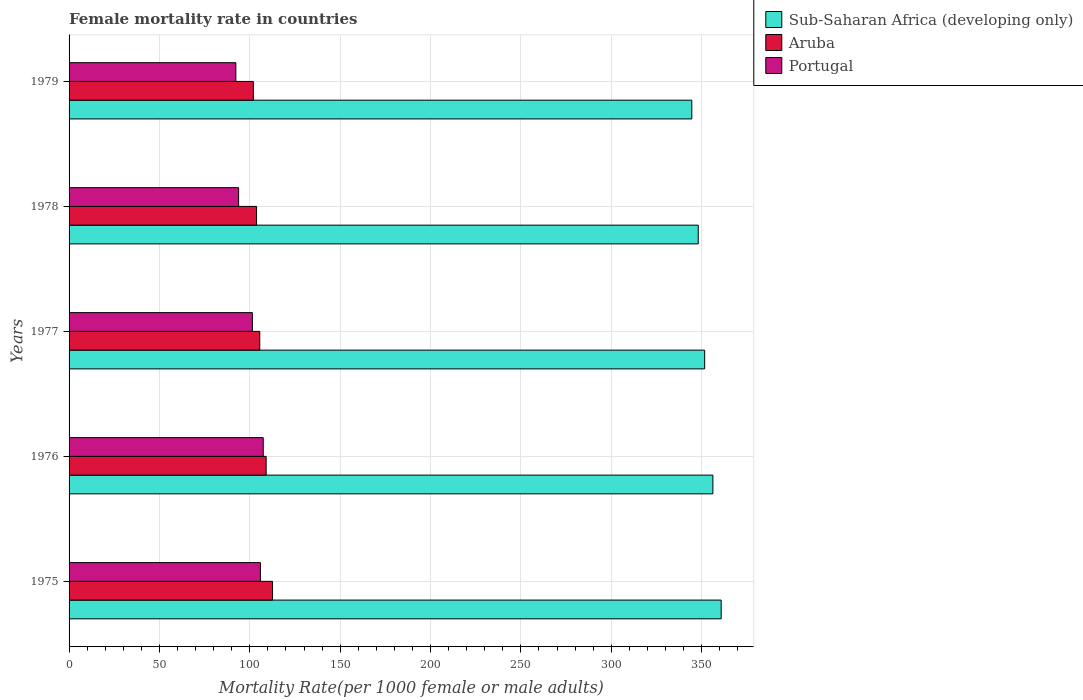How many groups of bars are there?
Your answer should be compact. 5. Are the number of bars per tick equal to the number of legend labels?
Keep it short and to the point. Yes. How many bars are there on the 1st tick from the top?
Give a very brief answer. 3. In how many cases, is the number of bars for a given year not equal to the number of legend labels?
Offer a very short reply. 0. What is the female mortality rate in Aruba in 1978?
Give a very brief answer. 103.74. Across all years, what is the maximum female mortality rate in Portugal?
Make the answer very short. 107.44. Across all years, what is the minimum female mortality rate in Portugal?
Ensure brevity in your answer.  92.29. In which year was the female mortality rate in Portugal maximum?
Make the answer very short. 1976. In which year was the female mortality rate in Portugal minimum?
Offer a very short reply. 1979. What is the total female mortality rate in Sub-Saharan Africa (developing only) in the graph?
Keep it short and to the point. 1761.43. What is the difference between the female mortality rate in Sub-Saharan Africa (developing only) in 1975 and that in 1976?
Your answer should be compact. 4.58. What is the difference between the female mortality rate in Portugal in 1977 and the female mortality rate in Sub-Saharan Africa (developing only) in 1976?
Offer a terse response. -254.81. What is the average female mortality rate in Sub-Saharan Africa (developing only) per year?
Your answer should be compact. 352.29. In the year 1979, what is the difference between the female mortality rate in Sub-Saharan Africa (developing only) and female mortality rate in Portugal?
Offer a terse response. 252.28. What is the ratio of the female mortality rate in Sub-Saharan Africa (developing only) in 1975 to that in 1979?
Your answer should be very brief. 1.05. Is the female mortality rate in Portugal in 1975 less than that in 1976?
Your answer should be compact. Yes. Is the difference between the female mortality rate in Sub-Saharan Africa (developing only) in 1978 and 1979 greater than the difference between the female mortality rate in Portugal in 1978 and 1979?
Ensure brevity in your answer.  Yes. What is the difference between the highest and the second highest female mortality rate in Portugal?
Keep it short and to the point. 1.57. What is the difference between the highest and the lowest female mortality rate in Portugal?
Make the answer very short. 15.15. In how many years, is the female mortality rate in Portugal greater than the average female mortality rate in Portugal taken over all years?
Offer a terse response. 3. What does the 3rd bar from the top in 1979 represents?
Your answer should be very brief. Sub-Saharan Africa (developing only). What does the 1st bar from the bottom in 1978 represents?
Give a very brief answer. Sub-Saharan Africa (developing only). How many bars are there?
Make the answer very short. 15. What is the title of the graph?
Provide a short and direct response. Female mortality rate in countries. Does "Sweden" appear as one of the legend labels in the graph?
Your response must be concise. No. What is the label or title of the X-axis?
Provide a short and direct response. Mortality Rate(per 1000 female or male adults). What is the Mortality Rate(per 1000 female or male adults) in Sub-Saharan Africa (developing only) in 1975?
Offer a very short reply. 360.82. What is the Mortality Rate(per 1000 female or male adults) of Aruba in 1975?
Give a very brief answer. 112.58. What is the Mortality Rate(per 1000 female or male adults) in Portugal in 1975?
Your answer should be compact. 105.87. What is the Mortality Rate(per 1000 female or male adults) in Sub-Saharan Africa (developing only) in 1976?
Offer a very short reply. 356.24. What is the Mortality Rate(per 1000 female or male adults) in Aruba in 1976?
Offer a very short reply. 109.05. What is the Mortality Rate(per 1000 female or male adults) in Portugal in 1976?
Your answer should be compact. 107.44. What is the Mortality Rate(per 1000 female or male adults) in Sub-Saharan Africa (developing only) in 1977?
Your answer should be compact. 351.68. What is the Mortality Rate(per 1000 female or male adults) of Aruba in 1977?
Your response must be concise. 105.51. What is the Mortality Rate(per 1000 female or male adults) in Portugal in 1977?
Your answer should be compact. 101.43. What is the Mortality Rate(per 1000 female or male adults) in Sub-Saharan Africa (developing only) in 1978?
Make the answer very short. 348.13. What is the Mortality Rate(per 1000 female or male adults) of Aruba in 1978?
Give a very brief answer. 103.74. What is the Mortality Rate(per 1000 female or male adults) of Portugal in 1978?
Offer a very short reply. 93.82. What is the Mortality Rate(per 1000 female or male adults) of Sub-Saharan Africa (developing only) in 1979?
Provide a succinct answer. 344.57. What is the Mortality Rate(per 1000 female or male adults) in Aruba in 1979?
Provide a succinct answer. 101.97. What is the Mortality Rate(per 1000 female or male adults) of Portugal in 1979?
Give a very brief answer. 92.29. Across all years, what is the maximum Mortality Rate(per 1000 female or male adults) in Sub-Saharan Africa (developing only)?
Your answer should be very brief. 360.82. Across all years, what is the maximum Mortality Rate(per 1000 female or male adults) of Aruba?
Give a very brief answer. 112.58. Across all years, what is the maximum Mortality Rate(per 1000 female or male adults) in Portugal?
Provide a succinct answer. 107.44. Across all years, what is the minimum Mortality Rate(per 1000 female or male adults) of Sub-Saharan Africa (developing only)?
Offer a very short reply. 344.57. Across all years, what is the minimum Mortality Rate(per 1000 female or male adults) in Aruba?
Give a very brief answer. 101.97. Across all years, what is the minimum Mortality Rate(per 1000 female or male adults) of Portugal?
Offer a terse response. 92.29. What is the total Mortality Rate(per 1000 female or male adults) of Sub-Saharan Africa (developing only) in the graph?
Provide a short and direct response. 1761.43. What is the total Mortality Rate(per 1000 female or male adults) in Aruba in the graph?
Offer a very short reply. 532.85. What is the total Mortality Rate(per 1000 female or male adults) in Portugal in the graph?
Your response must be concise. 500.85. What is the difference between the Mortality Rate(per 1000 female or male adults) in Sub-Saharan Africa (developing only) in 1975 and that in 1976?
Provide a succinct answer. 4.58. What is the difference between the Mortality Rate(per 1000 female or male adults) in Aruba in 1975 and that in 1976?
Make the answer very short. 3.54. What is the difference between the Mortality Rate(per 1000 female or male adults) of Portugal in 1975 and that in 1976?
Ensure brevity in your answer.  -1.57. What is the difference between the Mortality Rate(per 1000 female or male adults) in Sub-Saharan Africa (developing only) in 1975 and that in 1977?
Provide a succinct answer. 9.14. What is the difference between the Mortality Rate(per 1000 female or male adults) of Aruba in 1975 and that in 1977?
Offer a very short reply. 7.07. What is the difference between the Mortality Rate(per 1000 female or male adults) of Portugal in 1975 and that in 1977?
Ensure brevity in your answer.  4.44. What is the difference between the Mortality Rate(per 1000 female or male adults) of Sub-Saharan Africa (developing only) in 1975 and that in 1978?
Make the answer very short. 12.69. What is the difference between the Mortality Rate(per 1000 female or male adults) of Aruba in 1975 and that in 1978?
Offer a very short reply. 8.84. What is the difference between the Mortality Rate(per 1000 female or male adults) of Portugal in 1975 and that in 1978?
Keep it short and to the point. 12.05. What is the difference between the Mortality Rate(per 1000 female or male adults) in Sub-Saharan Africa (developing only) in 1975 and that in 1979?
Your answer should be very brief. 16.25. What is the difference between the Mortality Rate(per 1000 female or male adults) in Aruba in 1975 and that in 1979?
Offer a very short reply. 10.62. What is the difference between the Mortality Rate(per 1000 female or male adults) of Portugal in 1975 and that in 1979?
Keep it short and to the point. 13.58. What is the difference between the Mortality Rate(per 1000 female or male adults) of Sub-Saharan Africa (developing only) in 1976 and that in 1977?
Give a very brief answer. 4.56. What is the difference between the Mortality Rate(per 1000 female or male adults) in Aruba in 1976 and that in 1977?
Your response must be concise. 3.54. What is the difference between the Mortality Rate(per 1000 female or male adults) in Portugal in 1976 and that in 1977?
Offer a terse response. 6.01. What is the difference between the Mortality Rate(per 1000 female or male adults) in Sub-Saharan Africa (developing only) in 1976 and that in 1978?
Give a very brief answer. 8.11. What is the difference between the Mortality Rate(per 1000 female or male adults) of Aruba in 1976 and that in 1978?
Your answer should be compact. 5.31. What is the difference between the Mortality Rate(per 1000 female or male adults) in Portugal in 1976 and that in 1978?
Provide a succinct answer. 13.62. What is the difference between the Mortality Rate(per 1000 female or male adults) in Sub-Saharan Africa (developing only) in 1976 and that in 1979?
Offer a terse response. 11.67. What is the difference between the Mortality Rate(per 1000 female or male adults) in Aruba in 1976 and that in 1979?
Offer a very short reply. 7.08. What is the difference between the Mortality Rate(per 1000 female or male adults) of Portugal in 1976 and that in 1979?
Ensure brevity in your answer.  15.15. What is the difference between the Mortality Rate(per 1000 female or male adults) in Sub-Saharan Africa (developing only) in 1977 and that in 1978?
Your response must be concise. 3.55. What is the difference between the Mortality Rate(per 1000 female or male adults) of Aruba in 1977 and that in 1978?
Keep it short and to the point. 1.77. What is the difference between the Mortality Rate(per 1000 female or male adults) in Portugal in 1977 and that in 1978?
Provide a short and direct response. 7.61. What is the difference between the Mortality Rate(per 1000 female or male adults) in Sub-Saharan Africa (developing only) in 1977 and that in 1979?
Your answer should be compact. 7.11. What is the difference between the Mortality Rate(per 1000 female or male adults) in Aruba in 1977 and that in 1979?
Keep it short and to the point. 3.54. What is the difference between the Mortality Rate(per 1000 female or male adults) of Portugal in 1977 and that in 1979?
Your answer should be compact. 9.14. What is the difference between the Mortality Rate(per 1000 female or male adults) of Sub-Saharan Africa (developing only) in 1978 and that in 1979?
Give a very brief answer. 3.56. What is the difference between the Mortality Rate(per 1000 female or male adults) in Aruba in 1978 and that in 1979?
Your answer should be compact. 1.77. What is the difference between the Mortality Rate(per 1000 female or male adults) of Portugal in 1978 and that in 1979?
Your answer should be very brief. 1.53. What is the difference between the Mortality Rate(per 1000 female or male adults) of Sub-Saharan Africa (developing only) in 1975 and the Mortality Rate(per 1000 female or male adults) of Aruba in 1976?
Your answer should be compact. 251.77. What is the difference between the Mortality Rate(per 1000 female or male adults) of Sub-Saharan Africa (developing only) in 1975 and the Mortality Rate(per 1000 female or male adults) of Portugal in 1976?
Your answer should be very brief. 253.38. What is the difference between the Mortality Rate(per 1000 female or male adults) in Aruba in 1975 and the Mortality Rate(per 1000 female or male adults) in Portugal in 1976?
Provide a short and direct response. 5.15. What is the difference between the Mortality Rate(per 1000 female or male adults) of Sub-Saharan Africa (developing only) in 1975 and the Mortality Rate(per 1000 female or male adults) of Aruba in 1977?
Give a very brief answer. 255.31. What is the difference between the Mortality Rate(per 1000 female or male adults) in Sub-Saharan Africa (developing only) in 1975 and the Mortality Rate(per 1000 female or male adults) in Portugal in 1977?
Ensure brevity in your answer.  259.39. What is the difference between the Mortality Rate(per 1000 female or male adults) in Aruba in 1975 and the Mortality Rate(per 1000 female or male adults) in Portugal in 1977?
Provide a short and direct response. 11.15. What is the difference between the Mortality Rate(per 1000 female or male adults) of Sub-Saharan Africa (developing only) in 1975 and the Mortality Rate(per 1000 female or male adults) of Aruba in 1978?
Provide a short and direct response. 257.08. What is the difference between the Mortality Rate(per 1000 female or male adults) of Sub-Saharan Africa (developing only) in 1975 and the Mortality Rate(per 1000 female or male adults) of Portugal in 1978?
Provide a succinct answer. 267. What is the difference between the Mortality Rate(per 1000 female or male adults) of Aruba in 1975 and the Mortality Rate(per 1000 female or male adults) of Portugal in 1978?
Your answer should be compact. 18.76. What is the difference between the Mortality Rate(per 1000 female or male adults) of Sub-Saharan Africa (developing only) in 1975 and the Mortality Rate(per 1000 female or male adults) of Aruba in 1979?
Your response must be concise. 258.85. What is the difference between the Mortality Rate(per 1000 female or male adults) of Sub-Saharan Africa (developing only) in 1975 and the Mortality Rate(per 1000 female or male adults) of Portugal in 1979?
Your answer should be compact. 268.53. What is the difference between the Mortality Rate(per 1000 female or male adults) of Aruba in 1975 and the Mortality Rate(per 1000 female or male adults) of Portugal in 1979?
Keep it short and to the point. 20.29. What is the difference between the Mortality Rate(per 1000 female or male adults) of Sub-Saharan Africa (developing only) in 1976 and the Mortality Rate(per 1000 female or male adults) of Aruba in 1977?
Offer a very short reply. 250.72. What is the difference between the Mortality Rate(per 1000 female or male adults) of Sub-Saharan Africa (developing only) in 1976 and the Mortality Rate(per 1000 female or male adults) of Portugal in 1977?
Keep it short and to the point. 254.81. What is the difference between the Mortality Rate(per 1000 female or male adults) in Aruba in 1976 and the Mortality Rate(per 1000 female or male adults) in Portugal in 1977?
Provide a succinct answer. 7.62. What is the difference between the Mortality Rate(per 1000 female or male adults) in Sub-Saharan Africa (developing only) in 1976 and the Mortality Rate(per 1000 female or male adults) in Aruba in 1978?
Give a very brief answer. 252.5. What is the difference between the Mortality Rate(per 1000 female or male adults) of Sub-Saharan Africa (developing only) in 1976 and the Mortality Rate(per 1000 female or male adults) of Portugal in 1978?
Provide a succinct answer. 262.42. What is the difference between the Mortality Rate(per 1000 female or male adults) in Aruba in 1976 and the Mortality Rate(per 1000 female or male adults) in Portugal in 1978?
Offer a terse response. 15.23. What is the difference between the Mortality Rate(per 1000 female or male adults) in Sub-Saharan Africa (developing only) in 1976 and the Mortality Rate(per 1000 female or male adults) in Aruba in 1979?
Provide a short and direct response. 254.27. What is the difference between the Mortality Rate(per 1000 female or male adults) in Sub-Saharan Africa (developing only) in 1976 and the Mortality Rate(per 1000 female or male adults) in Portugal in 1979?
Offer a terse response. 263.94. What is the difference between the Mortality Rate(per 1000 female or male adults) of Aruba in 1976 and the Mortality Rate(per 1000 female or male adults) of Portugal in 1979?
Offer a very short reply. 16.76. What is the difference between the Mortality Rate(per 1000 female or male adults) of Sub-Saharan Africa (developing only) in 1977 and the Mortality Rate(per 1000 female or male adults) of Aruba in 1978?
Your answer should be compact. 247.94. What is the difference between the Mortality Rate(per 1000 female or male adults) of Sub-Saharan Africa (developing only) in 1977 and the Mortality Rate(per 1000 female or male adults) of Portugal in 1978?
Your answer should be compact. 257.86. What is the difference between the Mortality Rate(per 1000 female or male adults) of Aruba in 1977 and the Mortality Rate(per 1000 female or male adults) of Portugal in 1978?
Ensure brevity in your answer.  11.69. What is the difference between the Mortality Rate(per 1000 female or male adults) in Sub-Saharan Africa (developing only) in 1977 and the Mortality Rate(per 1000 female or male adults) in Aruba in 1979?
Offer a terse response. 249.71. What is the difference between the Mortality Rate(per 1000 female or male adults) of Sub-Saharan Africa (developing only) in 1977 and the Mortality Rate(per 1000 female or male adults) of Portugal in 1979?
Provide a short and direct response. 259.39. What is the difference between the Mortality Rate(per 1000 female or male adults) of Aruba in 1977 and the Mortality Rate(per 1000 female or male adults) of Portugal in 1979?
Your answer should be compact. 13.22. What is the difference between the Mortality Rate(per 1000 female or male adults) of Sub-Saharan Africa (developing only) in 1978 and the Mortality Rate(per 1000 female or male adults) of Aruba in 1979?
Ensure brevity in your answer.  246.16. What is the difference between the Mortality Rate(per 1000 female or male adults) of Sub-Saharan Africa (developing only) in 1978 and the Mortality Rate(per 1000 female or male adults) of Portugal in 1979?
Provide a succinct answer. 255.84. What is the difference between the Mortality Rate(per 1000 female or male adults) in Aruba in 1978 and the Mortality Rate(per 1000 female or male adults) in Portugal in 1979?
Make the answer very short. 11.45. What is the average Mortality Rate(per 1000 female or male adults) of Sub-Saharan Africa (developing only) per year?
Provide a succinct answer. 352.29. What is the average Mortality Rate(per 1000 female or male adults) in Aruba per year?
Give a very brief answer. 106.57. What is the average Mortality Rate(per 1000 female or male adults) of Portugal per year?
Your answer should be compact. 100.17. In the year 1975, what is the difference between the Mortality Rate(per 1000 female or male adults) of Sub-Saharan Africa (developing only) and Mortality Rate(per 1000 female or male adults) of Aruba?
Give a very brief answer. 248.23. In the year 1975, what is the difference between the Mortality Rate(per 1000 female or male adults) in Sub-Saharan Africa (developing only) and Mortality Rate(per 1000 female or male adults) in Portugal?
Your response must be concise. 254.95. In the year 1975, what is the difference between the Mortality Rate(per 1000 female or male adults) in Aruba and Mortality Rate(per 1000 female or male adults) in Portugal?
Ensure brevity in your answer.  6.71. In the year 1976, what is the difference between the Mortality Rate(per 1000 female or male adults) in Sub-Saharan Africa (developing only) and Mortality Rate(per 1000 female or male adults) in Aruba?
Make the answer very short. 247.19. In the year 1976, what is the difference between the Mortality Rate(per 1000 female or male adults) of Sub-Saharan Africa (developing only) and Mortality Rate(per 1000 female or male adults) of Portugal?
Offer a terse response. 248.8. In the year 1976, what is the difference between the Mortality Rate(per 1000 female or male adults) of Aruba and Mortality Rate(per 1000 female or male adults) of Portugal?
Your response must be concise. 1.61. In the year 1977, what is the difference between the Mortality Rate(per 1000 female or male adults) of Sub-Saharan Africa (developing only) and Mortality Rate(per 1000 female or male adults) of Aruba?
Your response must be concise. 246.17. In the year 1977, what is the difference between the Mortality Rate(per 1000 female or male adults) of Sub-Saharan Africa (developing only) and Mortality Rate(per 1000 female or male adults) of Portugal?
Keep it short and to the point. 250.25. In the year 1977, what is the difference between the Mortality Rate(per 1000 female or male adults) of Aruba and Mortality Rate(per 1000 female or male adults) of Portugal?
Ensure brevity in your answer.  4.08. In the year 1978, what is the difference between the Mortality Rate(per 1000 female or male adults) in Sub-Saharan Africa (developing only) and Mortality Rate(per 1000 female or male adults) in Aruba?
Offer a terse response. 244.39. In the year 1978, what is the difference between the Mortality Rate(per 1000 female or male adults) in Sub-Saharan Africa (developing only) and Mortality Rate(per 1000 female or male adults) in Portugal?
Give a very brief answer. 254.31. In the year 1978, what is the difference between the Mortality Rate(per 1000 female or male adults) in Aruba and Mortality Rate(per 1000 female or male adults) in Portugal?
Your answer should be compact. 9.92. In the year 1979, what is the difference between the Mortality Rate(per 1000 female or male adults) in Sub-Saharan Africa (developing only) and Mortality Rate(per 1000 female or male adults) in Aruba?
Your answer should be compact. 242.6. In the year 1979, what is the difference between the Mortality Rate(per 1000 female or male adults) of Sub-Saharan Africa (developing only) and Mortality Rate(per 1000 female or male adults) of Portugal?
Make the answer very short. 252.28. In the year 1979, what is the difference between the Mortality Rate(per 1000 female or male adults) in Aruba and Mortality Rate(per 1000 female or male adults) in Portugal?
Provide a succinct answer. 9.68. What is the ratio of the Mortality Rate(per 1000 female or male adults) of Sub-Saharan Africa (developing only) in 1975 to that in 1976?
Offer a terse response. 1.01. What is the ratio of the Mortality Rate(per 1000 female or male adults) in Aruba in 1975 to that in 1976?
Keep it short and to the point. 1.03. What is the ratio of the Mortality Rate(per 1000 female or male adults) in Portugal in 1975 to that in 1976?
Give a very brief answer. 0.99. What is the ratio of the Mortality Rate(per 1000 female or male adults) of Aruba in 1975 to that in 1977?
Your response must be concise. 1.07. What is the ratio of the Mortality Rate(per 1000 female or male adults) of Portugal in 1975 to that in 1977?
Offer a very short reply. 1.04. What is the ratio of the Mortality Rate(per 1000 female or male adults) of Sub-Saharan Africa (developing only) in 1975 to that in 1978?
Your response must be concise. 1.04. What is the ratio of the Mortality Rate(per 1000 female or male adults) in Aruba in 1975 to that in 1978?
Provide a short and direct response. 1.09. What is the ratio of the Mortality Rate(per 1000 female or male adults) of Portugal in 1975 to that in 1978?
Keep it short and to the point. 1.13. What is the ratio of the Mortality Rate(per 1000 female or male adults) of Sub-Saharan Africa (developing only) in 1975 to that in 1979?
Provide a succinct answer. 1.05. What is the ratio of the Mortality Rate(per 1000 female or male adults) of Aruba in 1975 to that in 1979?
Keep it short and to the point. 1.1. What is the ratio of the Mortality Rate(per 1000 female or male adults) of Portugal in 1975 to that in 1979?
Give a very brief answer. 1.15. What is the ratio of the Mortality Rate(per 1000 female or male adults) in Sub-Saharan Africa (developing only) in 1976 to that in 1977?
Give a very brief answer. 1.01. What is the ratio of the Mortality Rate(per 1000 female or male adults) of Aruba in 1976 to that in 1977?
Provide a succinct answer. 1.03. What is the ratio of the Mortality Rate(per 1000 female or male adults) of Portugal in 1976 to that in 1977?
Your answer should be compact. 1.06. What is the ratio of the Mortality Rate(per 1000 female or male adults) in Sub-Saharan Africa (developing only) in 1976 to that in 1978?
Ensure brevity in your answer.  1.02. What is the ratio of the Mortality Rate(per 1000 female or male adults) in Aruba in 1976 to that in 1978?
Provide a short and direct response. 1.05. What is the ratio of the Mortality Rate(per 1000 female or male adults) in Portugal in 1976 to that in 1978?
Keep it short and to the point. 1.15. What is the ratio of the Mortality Rate(per 1000 female or male adults) of Sub-Saharan Africa (developing only) in 1976 to that in 1979?
Provide a succinct answer. 1.03. What is the ratio of the Mortality Rate(per 1000 female or male adults) in Aruba in 1976 to that in 1979?
Offer a terse response. 1.07. What is the ratio of the Mortality Rate(per 1000 female or male adults) in Portugal in 1976 to that in 1979?
Your answer should be compact. 1.16. What is the ratio of the Mortality Rate(per 1000 female or male adults) of Sub-Saharan Africa (developing only) in 1977 to that in 1978?
Offer a very short reply. 1.01. What is the ratio of the Mortality Rate(per 1000 female or male adults) of Aruba in 1977 to that in 1978?
Ensure brevity in your answer.  1.02. What is the ratio of the Mortality Rate(per 1000 female or male adults) of Portugal in 1977 to that in 1978?
Keep it short and to the point. 1.08. What is the ratio of the Mortality Rate(per 1000 female or male adults) in Sub-Saharan Africa (developing only) in 1977 to that in 1979?
Your answer should be compact. 1.02. What is the ratio of the Mortality Rate(per 1000 female or male adults) in Aruba in 1977 to that in 1979?
Provide a succinct answer. 1.03. What is the ratio of the Mortality Rate(per 1000 female or male adults) of Portugal in 1977 to that in 1979?
Your answer should be compact. 1.1. What is the ratio of the Mortality Rate(per 1000 female or male adults) of Sub-Saharan Africa (developing only) in 1978 to that in 1979?
Your answer should be compact. 1.01. What is the ratio of the Mortality Rate(per 1000 female or male adults) of Aruba in 1978 to that in 1979?
Offer a very short reply. 1.02. What is the ratio of the Mortality Rate(per 1000 female or male adults) in Portugal in 1978 to that in 1979?
Your response must be concise. 1.02. What is the difference between the highest and the second highest Mortality Rate(per 1000 female or male adults) of Sub-Saharan Africa (developing only)?
Keep it short and to the point. 4.58. What is the difference between the highest and the second highest Mortality Rate(per 1000 female or male adults) of Aruba?
Your answer should be compact. 3.54. What is the difference between the highest and the second highest Mortality Rate(per 1000 female or male adults) of Portugal?
Make the answer very short. 1.57. What is the difference between the highest and the lowest Mortality Rate(per 1000 female or male adults) of Sub-Saharan Africa (developing only)?
Offer a very short reply. 16.25. What is the difference between the highest and the lowest Mortality Rate(per 1000 female or male adults) in Aruba?
Your response must be concise. 10.62. What is the difference between the highest and the lowest Mortality Rate(per 1000 female or male adults) of Portugal?
Give a very brief answer. 15.15. 